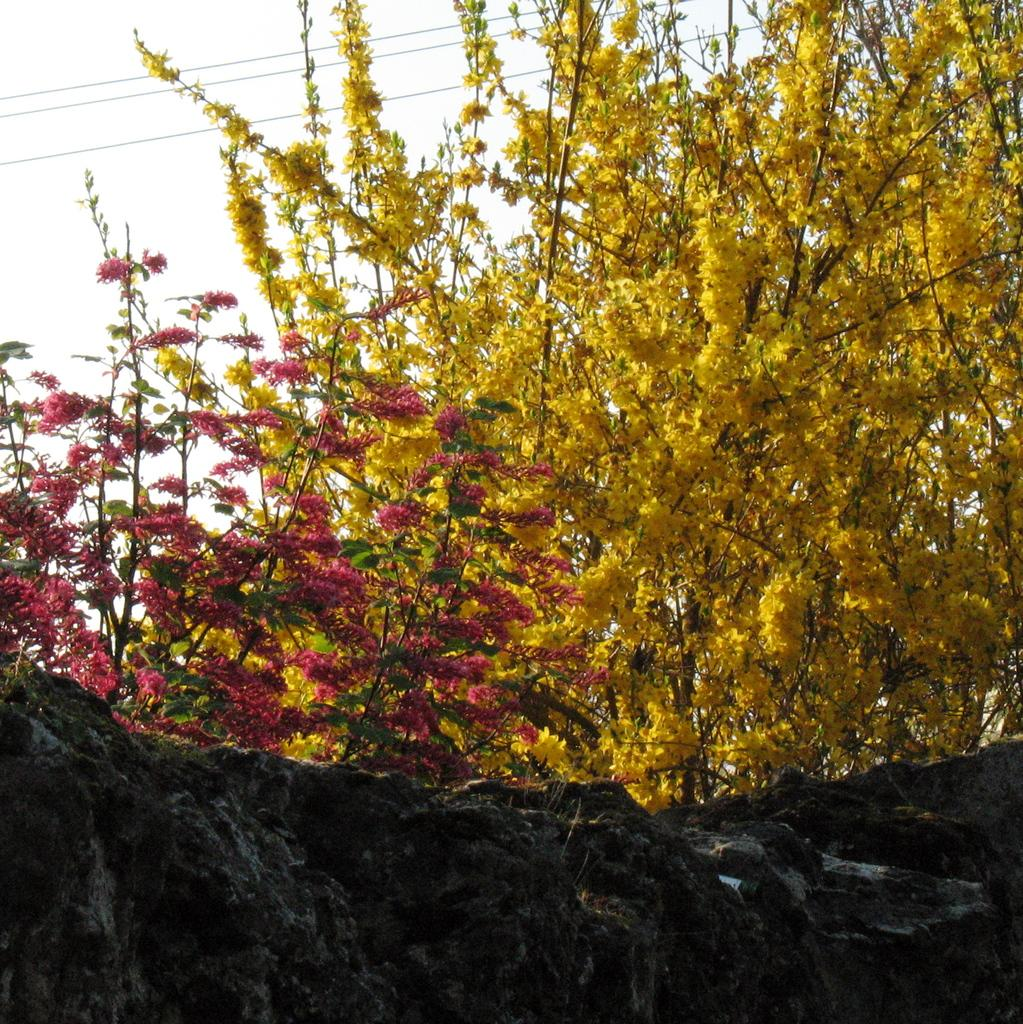What colors can be seen in the flowers in the image? The flowers in the image are in yellow and red colors. What else can be seen in the background of the image besides the flowers? There are wires visible in the background of the image. What is the color of the sky in the image? The sky appears to be white in color. What type of toothbrush is hanging from the wires in the image? There is no toothbrush present in the image; it only features flowers and wires in the background. 